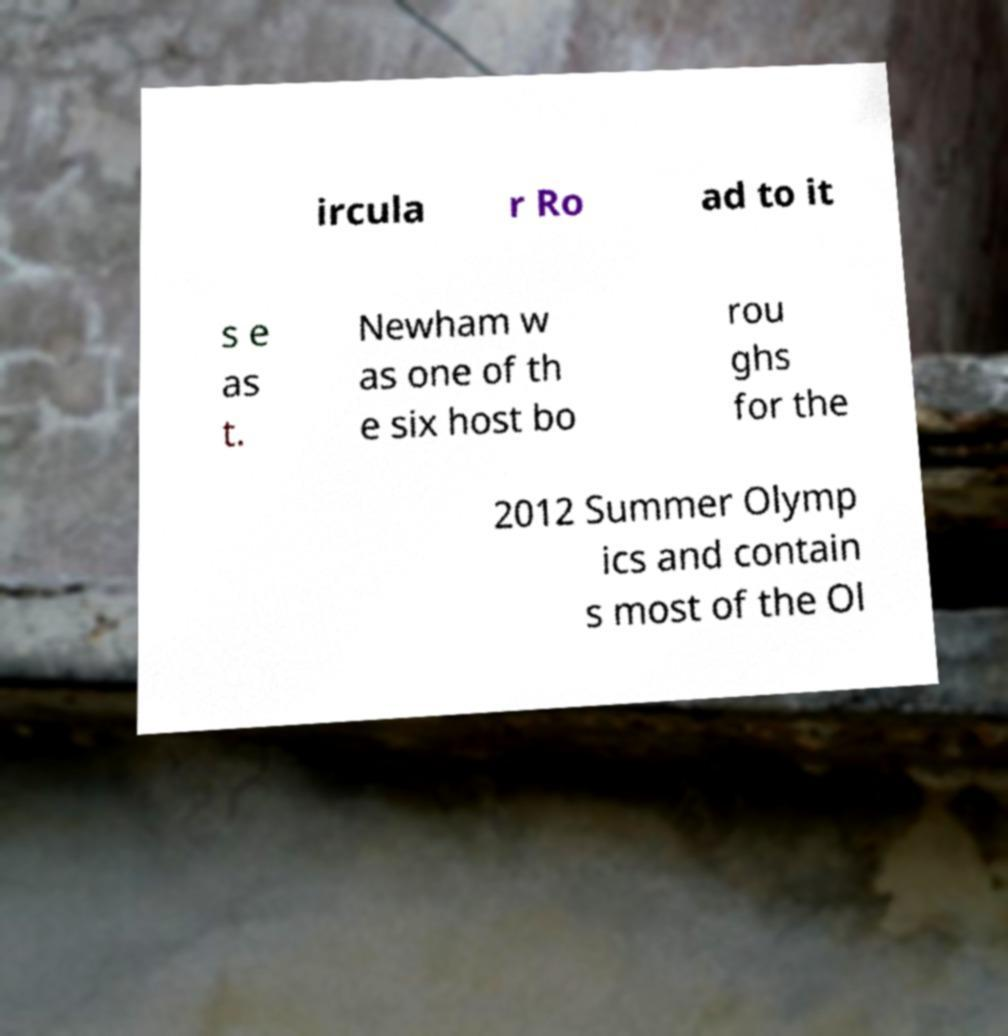Could you assist in decoding the text presented in this image and type it out clearly? ircula r Ro ad to it s e as t. Newham w as one of th e six host bo rou ghs for the 2012 Summer Olymp ics and contain s most of the Ol 